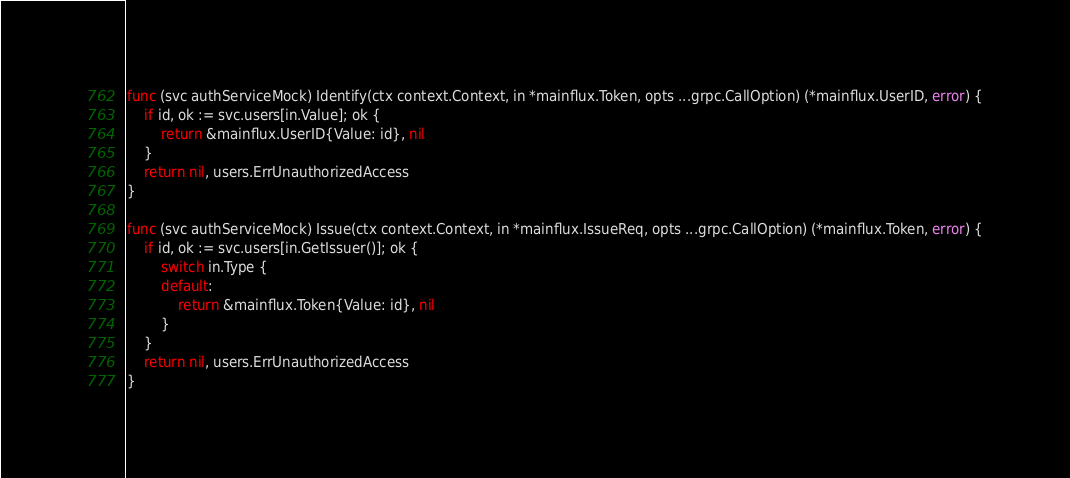<code> <loc_0><loc_0><loc_500><loc_500><_Go_>func (svc authServiceMock) Identify(ctx context.Context, in *mainflux.Token, opts ...grpc.CallOption) (*mainflux.UserID, error) {
	if id, ok := svc.users[in.Value]; ok {
		return &mainflux.UserID{Value: id}, nil
	}
	return nil, users.ErrUnauthorizedAccess
}

func (svc authServiceMock) Issue(ctx context.Context, in *mainflux.IssueReq, opts ...grpc.CallOption) (*mainflux.Token, error) {
	if id, ok := svc.users[in.GetIssuer()]; ok {
		switch in.Type {
		default:
			return &mainflux.Token{Value: id}, nil
		}
	}
	return nil, users.ErrUnauthorizedAccess
}
</code> 